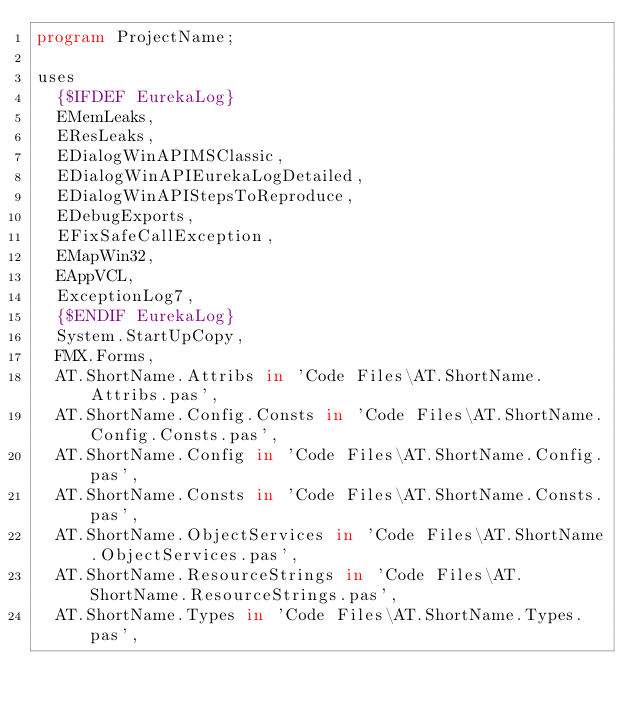Convert code to text. <code><loc_0><loc_0><loc_500><loc_500><_Pascal_>program ProjectName;

uses
  {$IFDEF EurekaLog}
  EMemLeaks,
  EResLeaks,
  EDialogWinAPIMSClassic,
  EDialogWinAPIEurekaLogDetailed,
  EDialogWinAPIStepsToReproduce,
  EDebugExports,
  EFixSafeCallException,
  EMapWin32,
  EAppVCL,
  ExceptionLog7,
  {$ENDIF EurekaLog}
  System.StartUpCopy,
  FMX.Forms,
  AT.ShortName.Attribs in 'Code Files\AT.ShortName.Attribs.pas',
  AT.ShortName.Config.Consts in 'Code Files\AT.ShortName.Config.Consts.pas',
  AT.ShortName.Config in 'Code Files\AT.ShortName.Config.pas',
  AT.ShortName.Consts in 'Code Files\AT.ShortName.Consts.pas',
  AT.ShortName.ObjectServices in 'Code Files\AT.ShortName.ObjectServices.pas',
  AT.ShortName.ResourceStrings in 'Code Files\AT.ShortName.ResourceStrings.pas',
  AT.ShortName.Types in 'Code Files\AT.ShortName.Types.pas',</code> 